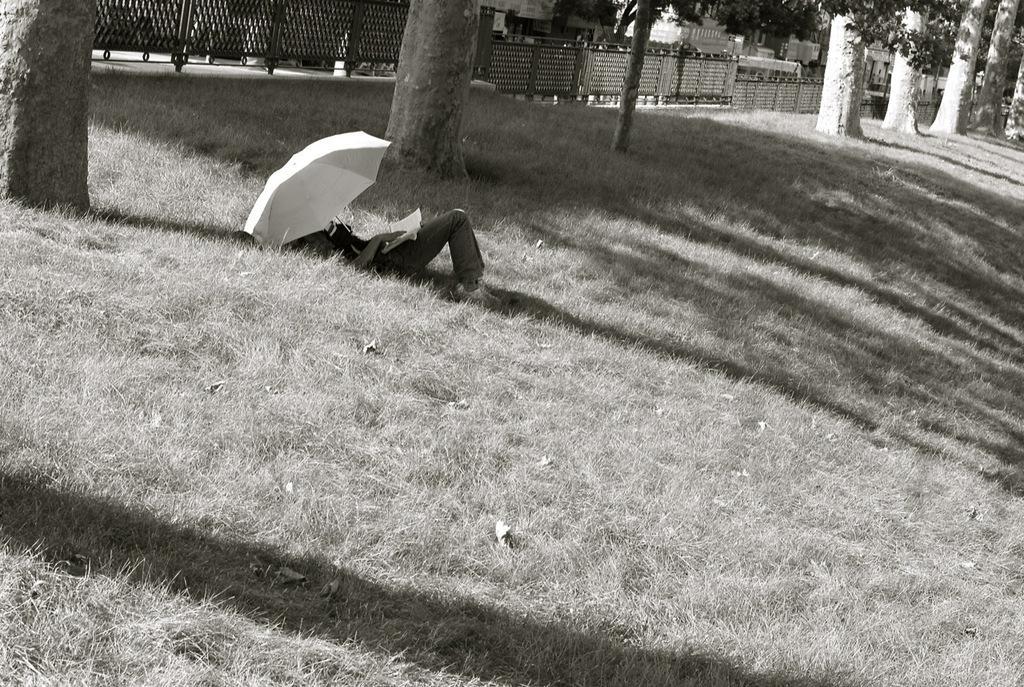Can you describe this image briefly? In this image we can see a person lying on the ground and holding a book, also we can see an umbrella, there are some buildings, trees, grass and fence. 